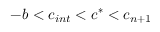Convert formula to latex. <formula><loc_0><loc_0><loc_500><loc_500>- b < c _ { i n t } < c ^ { * } < c _ { n + 1 }</formula> 